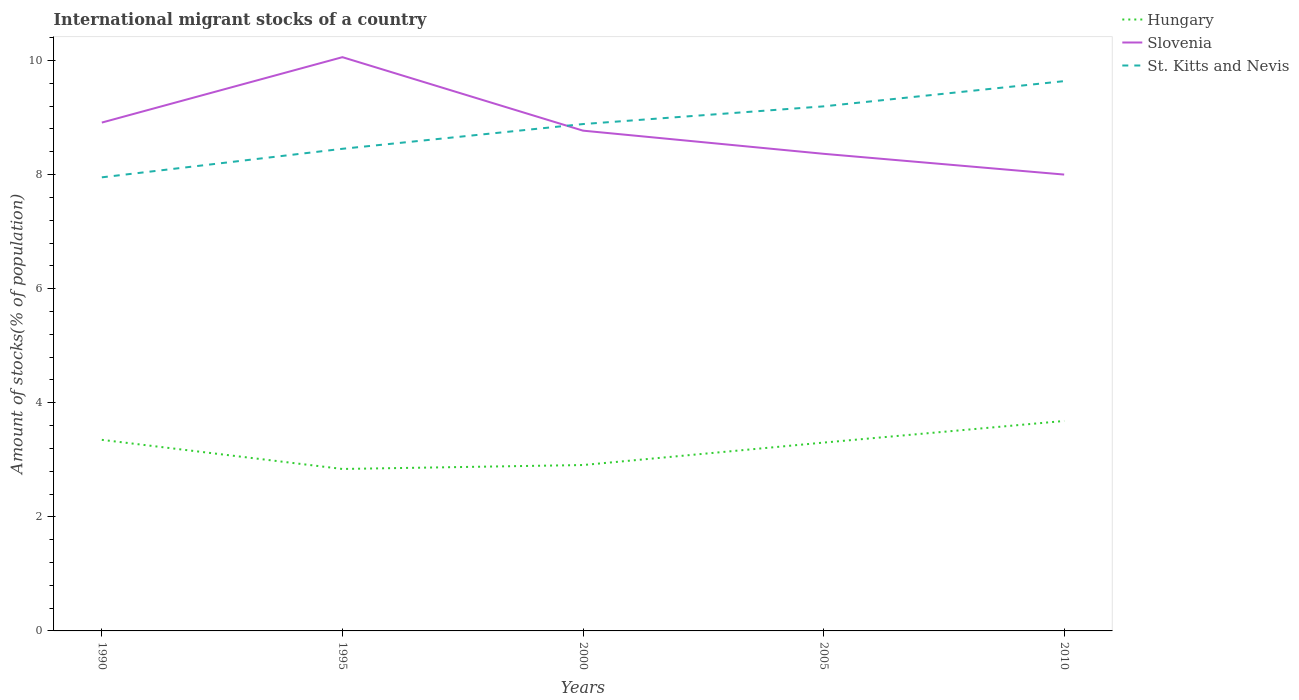How many different coloured lines are there?
Ensure brevity in your answer.  3. Across all years, what is the maximum amount of stocks in in St. Kitts and Nevis?
Your response must be concise. 7.95. In which year was the amount of stocks in in Slovenia maximum?
Your answer should be very brief. 2010. What is the total amount of stocks in in Slovenia in the graph?
Offer a very short reply. 2.06. What is the difference between the highest and the second highest amount of stocks in in Slovenia?
Provide a short and direct response. 2.06. How many lines are there?
Give a very brief answer. 3. How many years are there in the graph?
Give a very brief answer. 5. What is the title of the graph?
Offer a very short reply. International migrant stocks of a country. What is the label or title of the Y-axis?
Give a very brief answer. Amount of stocks(% of population). What is the Amount of stocks(% of population) of Hungary in 1990?
Make the answer very short. 3.35. What is the Amount of stocks(% of population) of Slovenia in 1990?
Your answer should be compact. 8.91. What is the Amount of stocks(% of population) in St. Kitts and Nevis in 1990?
Provide a succinct answer. 7.95. What is the Amount of stocks(% of population) in Hungary in 1995?
Offer a terse response. 2.84. What is the Amount of stocks(% of population) in Slovenia in 1995?
Provide a short and direct response. 10.06. What is the Amount of stocks(% of population) of St. Kitts and Nevis in 1995?
Provide a short and direct response. 8.45. What is the Amount of stocks(% of population) of Hungary in 2000?
Offer a very short reply. 2.91. What is the Amount of stocks(% of population) of Slovenia in 2000?
Provide a short and direct response. 8.77. What is the Amount of stocks(% of population) of St. Kitts and Nevis in 2000?
Keep it short and to the point. 8.89. What is the Amount of stocks(% of population) of Hungary in 2005?
Give a very brief answer. 3.3. What is the Amount of stocks(% of population) in Slovenia in 2005?
Keep it short and to the point. 8.36. What is the Amount of stocks(% of population) in St. Kitts and Nevis in 2005?
Make the answer very short. 9.2. What is the Amount of stocks(% of population) in Hungary in 2010?
Provide a short and direct response. 3.68. What is the Amount of stocks(% of population) in Slovenia in 2010?
Provide a succinct answer. 8. What is the Amount of stocks(% of population) of St. Kitts and Nevis in 2010?
Make the answer very short. 9.64. Across all years, what is the maximum Amount of stocks(% of population) in Hungary?
Your answer should be compact. 3.68. Across all years, what is the maximum Amount of stocks(% of population) in Slovenia?
Provide a short and direct response. 10.06. Across all years, what is the maximum Amount of stocks(% of population) of St. Kitts and Nevis?
Your answer should be very brief. 9.64. Across all years, what is the minimum Amount of stocks(% of population) in Hungary?
Your answer should be very brief. 2.84. Across all years, what is the minimum Amount of stocks(% of population) of Slovenia?
Keep it short and to the point. 8. Across all years, what is the minimum Amount of stocks(% of population) in St. Kitts and Nevis?
Your answer should be very brief. 7.95. What is the total Amount of stocks(% of population) of Hungary in the graph?
Make the answer very short. 16.08. What is the total Amount of stocks(% of population) in Slovenia in the graph?
Offer a terse response. 44.11. What is the total Amount of stocks(% of population) of St. Kitts and Nevis in the graph?
Ensure brevity in your answer.  44.12. What is the difference between the Amount of stocks(% of population) in Hungary in 1990 and that in 1995?
Make the answer very short. 0.51. What is the difference between the Amount of stocks(% of population) in Slovenia in 1990 and that in 1995?
Keep it short and to the point. -1.15. What is the difference between the Amount of stocks(% of population) of St. Kitts and Nevis in 1990 and that in 1995?
Your answer should be compact. -0.5. What is the difference between the Amount of stocks(% of population) in Hungary in 1990 and that in 2000?
Make the answer very short. 0.44. What is the difference between the Amount of stocks(% of population) in Slovenia in 1990 and that in 2000?
Your answer should be compact. 0.14. What is the difference between the Amount of stocks(% of population) in St. Kitts and Nevis in 1990 and that in 2000?
Keep it short and to the point. -0.93. What is the difference between the Amount of stocks(% of population) of Hungary in 1990 and that in 2005?
Provide a short and direct response. 0.05. What is the difference between the Amount of stocks(% of population) in Slovenia in 1990 and that in 2005?
Offer a very short reply. 0.55. What is the difference between the Amount of stocks(% of population) of St. Kitts and Nevis in 1990 and that in 2005?
Provide a short and direct response. -1.24. What is the difference between the Amount of stocks(% of population) in Hungary in 1990 and that in 2010?
Offer a terse response. -0.33. What is the difference between the Amount of stocks(% of population) of Slovenia in 1990 and that in 2010?
Provide a succinct answer. 0.91. What is the difference between the Amount of stocks(% of population) of St. Kitts and Nevis in 1990 and that in 2010?
Provide a short and direct response. -1.69. What is the difference between the Amount of stocks(% of population) in Hungary in 1995 and that in 2000?
Your answer should be very brief. -0.07. What is the difference between the Amount of stocks(% of population) in Slovenia in 1995 and that in 2000?
Offer a terse response. 1.29. What is the difference between the Amount of stocks(% of population) in St. Kitts and Nevis in 1995 and that in 2000?
Your answer should be very brief. -0.43. What is the difference between the Amount of stocks(% of population) of Hungary in 1995 and that in 2005?
Your answer should be very brief. -0.46. What is the difference between the Amount of stocks(% of population) in Slovenia in 1995 and that in 2005?
Keep it short and to the point. 1.69. What is the difference between the Amount of stocks(% of population) of St. Kitts and Nevis in 1995 and that in 2005?
Ensure brevity in your answer.  -0.74. What is the difference between the Amount of stocks(% of population) in Hungary in 1995 and that in 2010?
Ensure brevity in your answer.  -0.84. What is the difference between the Amount of stocks(% of population) of Slovenia in 1995 and that in 2010?
Offer a terse response. 2.06. What is the difference between the Amount of stocks(% of population) in St. Kitts and Nevis in 1995 and that in 2010?
Give a very brief answer. -1.19. What is the difference between the Amount of stocks(% of population) of Hungary in 2000 and that in 2005?
Your response must be concise. -0.39. What is the difference between the Amount of stocks(% of population) of Slovenia in 2000 and that in 2005?
Offer a terse response. 0.41. What is the difference between the Amount of stocks(% of population) in St. Kitts and Nevis in 2000 and that in 2005?
Provide a short and direct response. -0.31. What is the difference between the Amount of stocks(% of population) in Hungary in 2000 and that in 2010?
Provide a short and direct response. -0.77. What is the difference between the Amount of stocks(% of population) in Slovenia in 2000 and that in 2010?
Make the answer very short. 0.77. What is the difference between the Amount of stocks(% of population) in St. Kitts and Nevis in 2000 and that in 2010?
Your answer should be very brief. -0.75. What is the difference between the Amount of stocks(% of population) of Hungary in 2005 and that in 2010?
Ensure brevity in your answer.  -0.38. What is the difference between the Amount of stocks(% of population) of Slovenia in 2005 and that in 2010?
Make the answer very short. 0.36. What is the difference between the Amount of stocks(% of population) of St. Kitts and Nevis in 2005 and that in 2010?
Offer a very short reply. -0.44. What is the difference between the Amount of stocks(% of population) in Hungary in 1990 and the Amount of stocks(% of population) in Slovenia in 1995?
Provide a succinct answer. -6.71. What is the difference between the Amount of stocks(% of population) in Hungary in 1990 and the Amount of stocks(% of population) in St. Kitts and Nevis in 1995?
Make the answer very short. -5.1. What is the difference between the Amount of stocks(% of population) in Slovenia in 1990 and the Amount of stocks(% of population) in St. Kitts and Nevis in 1995?
Make the answer very short. 0.46. What is the difference between the Amount of stocks(% of population) of Hungary in 1990 and the Amount of stocks(% of population) of Slovenia in 2000?
Provide a short and direct response. -5.42. What is the difference between the Amount of stocks(% of population) in Hungary in 1990 and the Amount of stocks(% of population) in St. Kitts and Nevis in 2000?
Give a very brief answer. -5.54. What is the difference between the Amount of stocks(% of population) in Slovenia in 1990 and the Amount of stocks(% of population) in St. Kitts and Nevis in 2000?
Your answer should be very brief. 0.03. What is the difference between the Amount of stocks(% of population) in Hungary in 1990 and the Amount of stocks(% of population) in Slovenia in 2005?
Make the answer very short. -5.01. What is the difference between the Amount of stocks(% of population) of Hungary in 1990 and the Amount of stocks(% of population) of St. Kitts and Nevis in 2005?
Make the answer very short. -5.85. What is the difference between the Amount of stocks(% of population) of Slovenia in 1990 and the Amount of stocks(% of population) of St. Kitts and Nevis in 2005?
Make the answer very short. -0.28. What is the difference between the Amount of stocks(% of population) of Hungary in 1990 and the Amount of stocks(% of population) of Slovenia in 2010?
Keep it short and to the point. -4.65. What is the difference between the Amount of stocks(% of population) of Hungary in 1990 and the Amount of stocks(% of population) of St. Kitts and Nevis in 2010?
Provide a short and direct response. -6.29. What is the difference between the Amount of stocks(% of population) in Slovenia in 1990 and the Amount of stocks(% of population) in St. Kitts and Nevis in 2010?
Offer a very short reply. -0.73. What is the difference between the Amount of stocks(% of population) in Hungary in 1995 and the Amount of stocks(% of population) in Slovenia in 2000?
Ensure brevity in your answer.  -5.93. What is the difference between the Amount of stocks(% of population) in Hungary in 1995 and the Amount of stocks(% of population) in St. Kitts and Nevis in 2000?
Your response must be concise. -6.05. What is the difference between the Amount of stocks(% of population) of Slovenia in 1995 and the Amount of stocks(% of population) of St. Kitts and Nevis in 2000?
Offer a terse response. 1.17. What is the difference between the Amount of stocks(% of population) in Hungary in 1995 and the Amount of stocks(% of population) in Slovenia in 2005?
Offer a very short reply. -5.53. What is the difference between the Amount of stocks(% of population) of Hungary in 1995 and the Amount of stocks(% of population) of St. Kitts and Nevis in 2005?
Offer a very short reply. -6.36. What is the difference between the Amount of stocks(% of population) in Slovenia in 1995 and the Amount of stocks(% of population) in St. Kitts and Nevis in 2005?
Offer a terse response. 0.86. What is the difference between the Amount of stocks(% of population) in Hungary in 1995 and the Amount of stocks(% of population) in Slovenia in 2010?
Make the answer very short. -5.16. What is the difference between the Amount of stocks(% of population) of Hungary in 1995 and the Amount of stocks(% of population) of St. Kitts and Nevis in 2010?
Your answer should be compact. -6.8. What is the difference between the Amount of stocks(% of population) in Slovenia in 1995 and the Amount of stocks(% of population) in St. Kitts and Nevis in 2010?
Provide a short and direct response. 0.42. What is the difference between the Amount of stocks(% of population) of Hungary in 2000 and the Amount of stocks(% of population) of Slovenia in 2005?
Give a very brief answer. -5.46. What is the difference between the Amount of stocks(% of population) of Hungary in 2000 and the Amount of stocks(% of population) of St. Kitts and Nevis in 2005?
Your answer should be compact. -6.29. What is the difference between the Amount of stocks(% of population) in Slovenia in 2000 and the Amount of stocks(% of population) in St. Kitts and Nevis in 2005?
Provide a short and direct response. -0.43. What is the difference between the Amount of stocks(% of population) of Hungary in 2000 and the Amount of stocks(% of population) of Slovenia in 2010?
Ensure brevity in your answer.  -5.09. What is the difference between the Amount of stocks(% of population) in Hungary in 2000 and the Amount of stocks(% of population) in St. Kitts and Nevis in 2010?
Offer a very short reply. -6.73. What is the difference between the Amount of stocks(% of population) in Slovenia in 2000 and the Amount of stocks(% of population) in St. Kitts and Nevis in 2010?
Ensure brevity in your answer.  -0.87. What is the difference between the Amount of stocks(% of population) of Hungary in 2005 and the Amount of stocks(% of population) of Slovenia in 2010?
Ensure brevity in your answer.  -4.7. What is the difference between the Amount of stocks(% of population) of Hungary in 2005 and the Amount of stocks(% of population) of St. Kitts and Nevis in 2010?
Give a very brief answer. -6.34. What is the difference between the Amount of stocks(% of population) in Slovenia in 2005 and the Amount of stocks(% of population) in St. Kitts and Nevis in 2010?
Your response must be concise. -1.27. What is the average Amount of stocks(% of population) in Hungary per year?
Give a very brief answer. 3.22. What is the average Amount of stocks(% of population) of Slovenia per year?
Offer a very short reply. 8.82. What is the average Amount of stocks(% of population) in St. Kitts and Nevis per year?
Offer a very short reply. 8.82. In the year 1990, what is the difference between the Amount of stocks(% of population) in Hungary and Amount of stocks(% of population) in Slovenia?
Offer a very short reply. -5.56. In the year 1990, what is the difference between the Amount of stocks(% of population) of Hungary and Amount of stocks(% of population) of St. Kitts and Nevis?
Offer a terse response. -4.6. In the year 1990, what is the difference between the Amount of stocks(% of population) of Slovenia and Amount of stocks(% of population) of St. Kitts and Nevis?
Ensure brevity in your answer.  0.96. In the year 1995, what is the difference between the Amount of stocks(% of population) in Hungary and Amount of stocks(% of population) in Slovenia?
Your response must be concise. -7.22. In the year 1995, what is the difference between the Amount of stocks(% of population) of Hungary and Amount of stocks(% of population) of St. Kitts and Nevis?
Your answer should be very brief. -5.61. In the year 1995, what is the difference between the Amount of stocks(% of population) of Slovenia and Amount of stocks(% of population) of St. Kitts and Nevis?
Keep it short and to the point. 1.61. In the year 2000, what is the difference between the Amount of stocks(% of population) of Hungary and Amount of stocks(% of population) of Slovenia?
Your answer should be compact. -5.86. In the year 2000, what is the difference between the Amount of stocks(% of population) in Hungary and Amount of stocks(% of population) in St. Kitts and Nevis?
Offer a very short reply. -5.98. In the year 2000, what is the difference between the Amount of stocks(% of population) of Slovenia and Amount of stocks(% of population) of St. Kitts and Nevis?
Provide a succinct answer. -0.12. In the year 2005, what is the difference between the Amount of stocks(% of population) of Hungary and Amount of stocks(% of population) of Slovenia?
Offer a terse response. -5.06. In the year 2005, what is the difference between the Amount of stocks(% of population) of Hungary and Amount of stocks(% of population) of St. Kitts and Nevis?
Your response must be concise. -5.89. In the year 2005, what is the difference between the Amount of stocks(% of population) of Slovenia and Amount of stocks(% of population) of St. Kitts and Nevis?
Offer a terse response. -0.83. In the year 2010, what is the difference between the Amount of stocks(% of population) of Hungary and Amount of stocks(% of population) of Slovenia?
Offer a terse response. -4.32. In the year 2010, what is the difference between the Amount of stocks(% of population) of Hungary and Amount of stocks(% of population) of St. Kitts and Nevis?
Ensure brevity in your answer.  -5.96. In the year 2010, what is the difference between the Amount of stocks(% of population) of Slovenia and Amount of stocks(% of population) of St. Kitts and Nevis?
Offer a very short reply. -1.64. What is the ratio of the Amount of stocks(% of population) of Hungary in 1990 to that in 1995?
Your answer should be compact. 1.18. What is the ratio of the Amount of stocks(% of population) in Slovenia in 1990 to that in 1995?
Provide a succinct answer. 0.89. What is the ratio of the Amount of stocks(% of population) of St. Kitts and Nevis in 1990 to that in 1995?
Ensure brevity in your answer.  0.94. What is the ratio of the Amount of stocks(% of population) in Hungary in 1990 to that in 2000?
Offer a very short reply. 1.15. What is the ratio of the Amount of stocks(% of population) of Slovenia in 1990 to that in 2000?
Offer a terse response. 1.02. What is the ratio of the Amount of stocks(% of population) of St. Kitts and Nevis in 1990 to that in 2000?
Make the answer very short. 0.89. What is the ratio of the Amount of stocks(% of population) of Hungary in 1990 to that in 2005?
Make the answer very short. 1.01. What is the ratio of the Amount of stocks(% of population) of Slovenia in 1990 to that in 2005?
Give a very brief answer. 1.07. What is the ratio of the Amount of stocks(% of population) in St. Kitts and Nevis in 1990 to that in 2005?
Give a very brief answer. 0.86. What is the ratio of the Amount of stocks(% of population) of Hungary in 1990 to that in 2010?
Your response must be concise. 0.91. What is the ratio of the Amount of stocks(% of population) in Slovenia in 1990 to that in 2010?
Make the answer very short. 1.11. What is the ratio of the Amount of stocks(% of population) of St. Kitts and Nevis in 1990 to that in 2010?
Keep it short and to the point. 0.82. What is the ratio of the Amount of stocks(% of population) of Hungary in 1995 to that in 2000?
Provide a succinct answer. 0.98. What is the ratio of the Amount of stocks(% of population) in Slovenia in 1995 to that in 2000?
Ensure brevity in your answer.  1.15. What is the ratio of the Amount of stocks(% of population) in St. Kitts and Nevis in 1995 to that in 2000?
Offer a terse response. 0.95. What is the ratio of the Amount of stocks(% of population) in Hungary in 1995 to that in 2005?
Your answer should be compact. 0.86. What is the ratio of the Amount of stocks(% of population) in Slovenia in 1995 to that in 2005?
Provide a short and direct response. 1.2. What is the ratio of the Amount of stocks(% of population) in St. Kitts and Nevis in 1995 to that in 2005?
Offer a terse response. 0.92. What is the ratio of the Amount of stocks(% of population) in Hungary in 1995 to that in 2010?
Your answer should be compact. 0.77. What is the ratio of the Amount of stocks(% of population) of Slovenia in 1995 to that in 2010?
Your answer should be very brief. 1.26. What is the ratio of the Amount of stocks(% of population) in St. Kitts and Nevis in 1995 to that in 2010?
Provide a succinct answer. 0.88. What is the ratio of the Amount of stocks(% of population) of Hungary in 2000 to that in 2005?
Your answer should be very brief. 0.88. What is the ratio of the Amount of stocks(% of population) of Slovenia in 2000 to that in 2005?
Give a very brief answer. 1.05. What is the ratio of the Amount of stocks(% of population) of St. Kitts and Nevis in 2000 to that in 2005?
Make the answer very short. 0.97. What is the ratio of the Amount of stocks(% of population) of Hungary in 2000 to that in 2010?
Give a very brief answer. 0.79. What is the ratio of the Amount of stocks(% of population) of Slovenia in 2000 to that in 2010?
Make the answer very short. 1.1. What is the ratio of the Amount of stocks(% of population) in St. Kitts and Nevis in 2000 to that in 2010?
Offer a very short reply. 0.92. What is the ratio of the Amount of stocks(% of population) in Hungary in 2005 to that in 2010?
Provide a succinct answer. 0.9. What is the ratio of the Amount of stocks(% of population) in Slovenia in 2005 to that in 2010?
Keep it short and to the point. 1.05. What is the ratio of the Amount of stocks(% of population) in St. Kitts and Nevis in 2005 to that in 2010?
Your answer should be compact. 0.95. What is the difference between the highest and the second highest Amount of stocks(% of population) in Hungary?
Your answer should be compact. 0.33. What is the difference between the highest and the second highest Amount of stocks(% of population) of Slovenia?
Make the answer very short. 1.15. What is the difference between the highest and the second highest Amount of stocks(% of population) of St. Kitts and Nevis?
Your answer should be very brief. 0.44. What is the difference between the highest and the lowest Amount of stocks(% of population) of Hungary?
Offer a very short reply. 0.84. What is the difference between the highest and the lowest Amount of stocks(% of population) of Slovenia?
Make the answer very short. 2.06. What is the difference between the highest and the lowest Amount of stocks(% of population) of St. Kitts and Nevis?
Offer a very short reply. 1.69. 